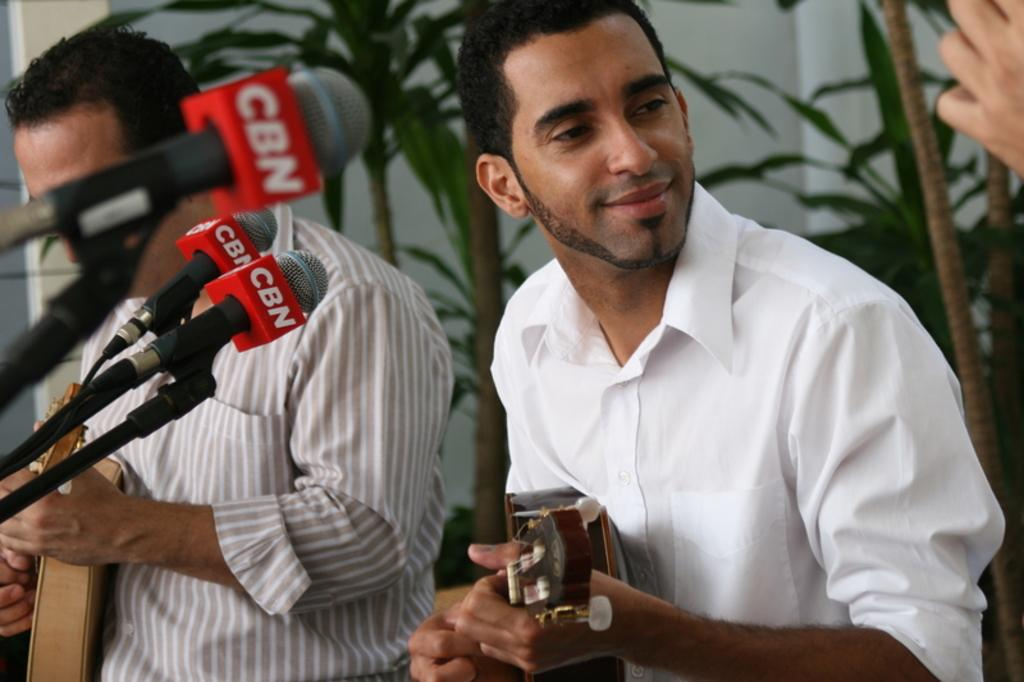How many people are in the image? There are two persons in the image. What are the persons wearing? The persons are wearing clothes. What are the persons doing in the image? The persons are playing guitars. What can be seen on the left side of the image? There are mics on the left side of the image. What type of vegetation is visible in the background of the image? There are plants in the background of the image. Can you tell me how many zebras are visible in the image? There are no zebras present in the image. What type of prose is being recited by the persons in the image? There is no indication in the image that the persons are reciting any prose; they are playing guitars. 